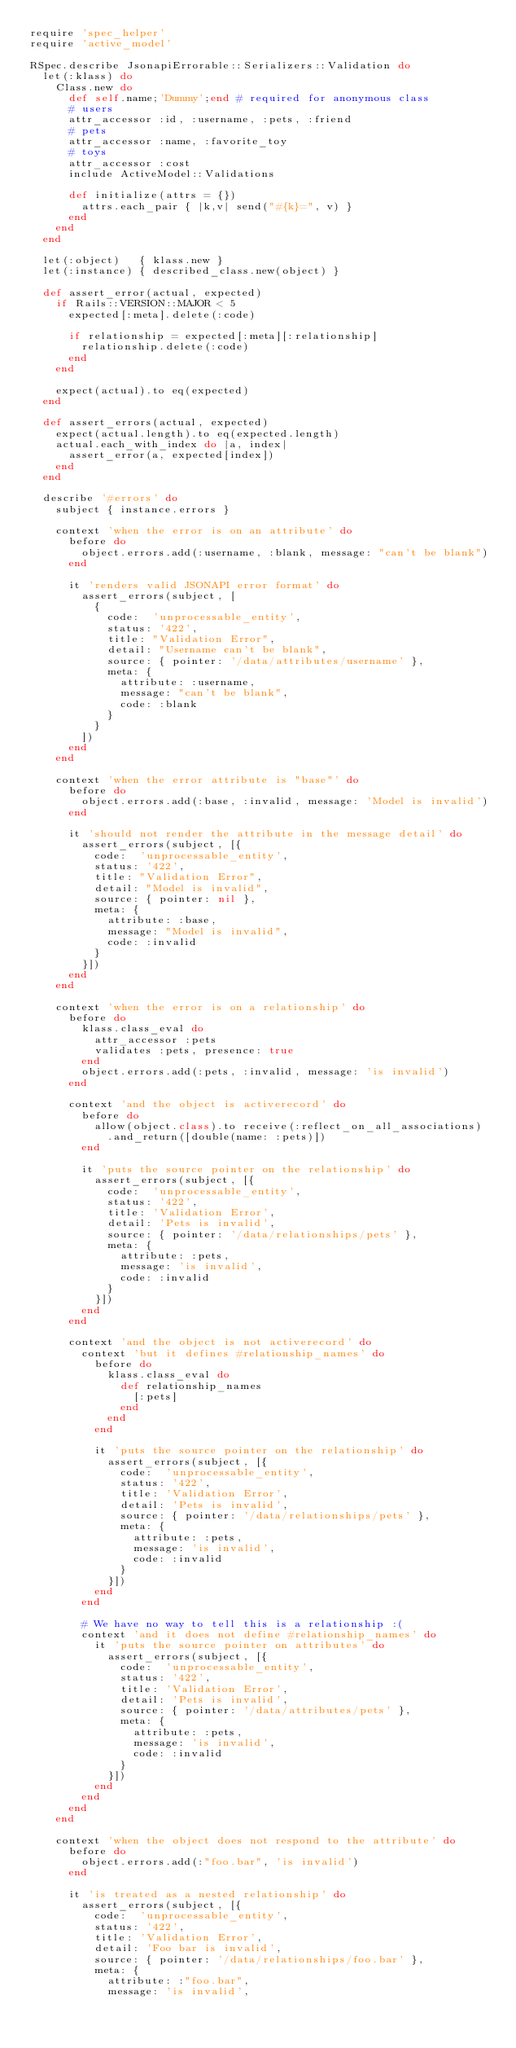Convert code to text. <code><loc_0><loc_0><loc_500><loc_500><_Ruby_>require 'spec_helper'
require 'active_model'

RSpec.describe JsonapiErrorable::Serializers::Validation do
  let(:klass) do
    Class.new do
      def self.name;'Dummy';end # required for anonymous class
      # users
      attr_accessor :id, :username, :pets, :friend
      # pets
      attr_accessor :name, :favorite_toy
      # toys
      attr_accessor :cost
      include ActiveModel::Validations

      def initialize(attrs = {})
        attrs.each_pair { |k,v| send("#{k}=", v) }
      end
    end
  end

  let(:object)   { klass.new }
  let(:instance) { described_class.new(object) }

  def assert_error(actual, expected)
    if Rails::VERSION::MAJOR < 5
      expected[:meta].delete(:code)

      if relationship = expected[:meta][:relationship]
        relationship.delete(:code)
      end
    end

    expect(actual).to eq(expected)
  end

  def assert_errors(actual, expected)
    expect(actual.length).to eq(expected.length)
    actual.each_with_index do |a, index|
      assert_error(a, expected[index])
    end
  end

  describe '#errors' do
    subject { instance.errors }

    context 'when the error is on an attribute' do
      before do
        object.errors.add(:username, :blank, message: "can't be blank")
      end

      it 'renders valid JSONAPI error format' do
        assert_errors(subject, [
          {
            code:  'unprocessable_entity',
            status: '422',
            title: "Validation Error",
            detail: "Username can't be blank",
            source: { pointer: '/data/attributes/username' },
            meta: {
              attribute: :username,
              message: "can't be blank",
              code: :blank
            }
          }
        ])
      end
    end

    context 'when the error attribute is "base"' do
      before do
        object.errors.add(:base, :invalid, message: 'Model is invalid')
      end

      it 'should not render the attribute in the message detail' do
        assert_errors(subject, [{
          code:  'unprocessable_entity',
          status: '422',
          title: "Validation Error",
          detail: "Model is invalid",
          source: { pointer: nil },
          meta: {
            attribute: :base,
            message: "Model is invalid",
            code: :invalid
          }
        }])
      end
    end

    context 'when the error is on a relationship' do
      before do
        klass.class_eval do
          attr_accessor :pets
          validates :pets, presence: true
        end
        object.errors.add(:pets, :invalid, message: 'is invalid')
      end

      context 'and the object is activerecord' do
        before do
          allow(object.class).to receive(:reflect_on_all_associations)
            .and_return([double(name: :pets)])
        end

        it 'puts the source pointer on the relationship' do
          assert_errors(subject, [{
            code:  'unprocessable_entity',
            status: '422',
            title: 'Validation Error',
            detail: 'Pets is invalid',
            source: { pointer: '/data/relationships/pets' },
            meta: {
              attribute: :pets,
              message: 'is invalid',
              code: :invalid
            }
          }])
        end
      end

      context 'and the object is not activerecord' do
        context 'but it defines #relationship_names' do
          before do
            klass.class_eval do
              def relationship_names
                [:pets]
              end
            end
          end

          it 'puts the source pointer on the relationship' do
            assert_errors(subject, [{
              code:  'unprocessable_entity',
              status: '422',
              title: 'Validation Error',
              detail: 'Pets is invalid',
              source: { pointer: '/data/relationships/pets' },
              meta: {
                attribute: :pets,
                message: 'is invalid',
                code: :invalid
              }
            }])
          end
        end

        # We have no way to tell this is a relationship :(
        context 'and it does not define #relationship_names' do
          it 'puts the source pointer on attributes' do
            assert_errors(subject, [{
              code:  'unprocessable_entity',
              status: '422',
              title: 'Validation Error',
              detail: 'Pets is invalid',
              source: { pointer: '/data/attributes/pets' },
              meta: {
                attribute: :pets,
                message: 'is invalid',
                code: :invalid
              }
            }])
          end
        end
      end
    end

    context 'when the object does not respond to the attribute' do
      before do
        object.errors.add(:"foo.bar", 'is invalid')
      end

      it 'is treated as a nested relationship' do
        assert_errors(subject, [{
          code:  'unprocessable_entity',
          status: '422',
          title: 'Validation Error',
          detail: 'Foo bar is invalid',
          source: { pointer: '/data/relationships/foo.bar' },
          meta: {
            attribute: :"foo.bar",
            message: 'is invalid',</code> 